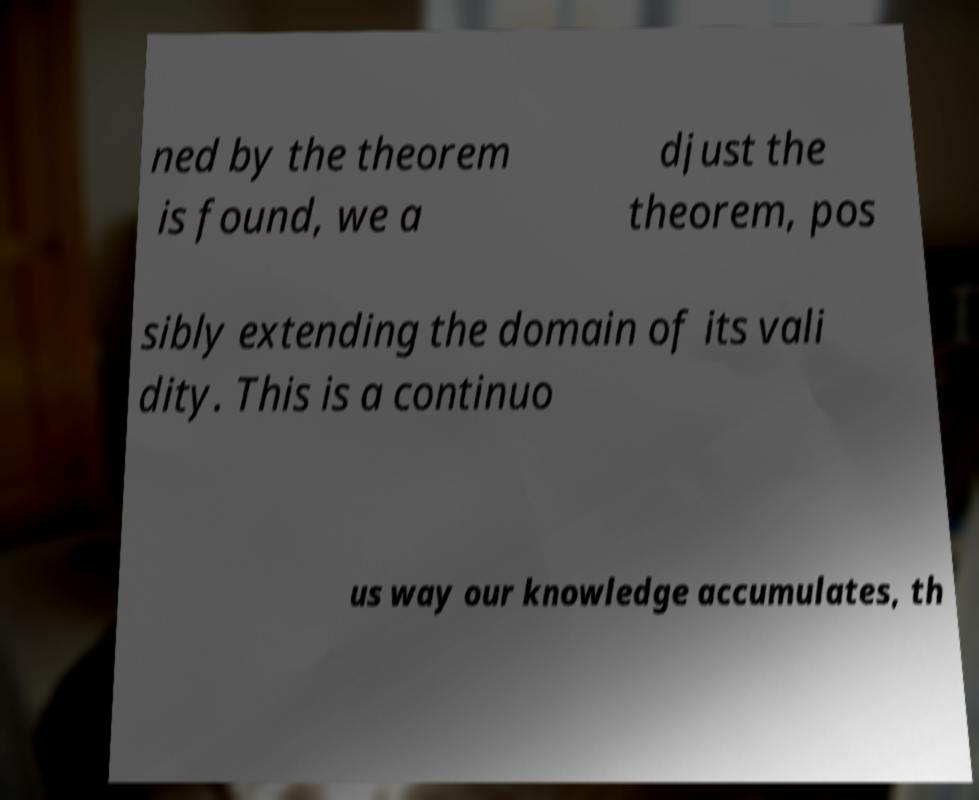Can you read and provide the text displayed in the image?This photo seems to have some interesting text. Can you extract and type it out for me? ned by the theorem is found, we a djust the theorem, pos sibly extending the domain of its vali dity. This is a continuo us way our knowledge accumulates, th 